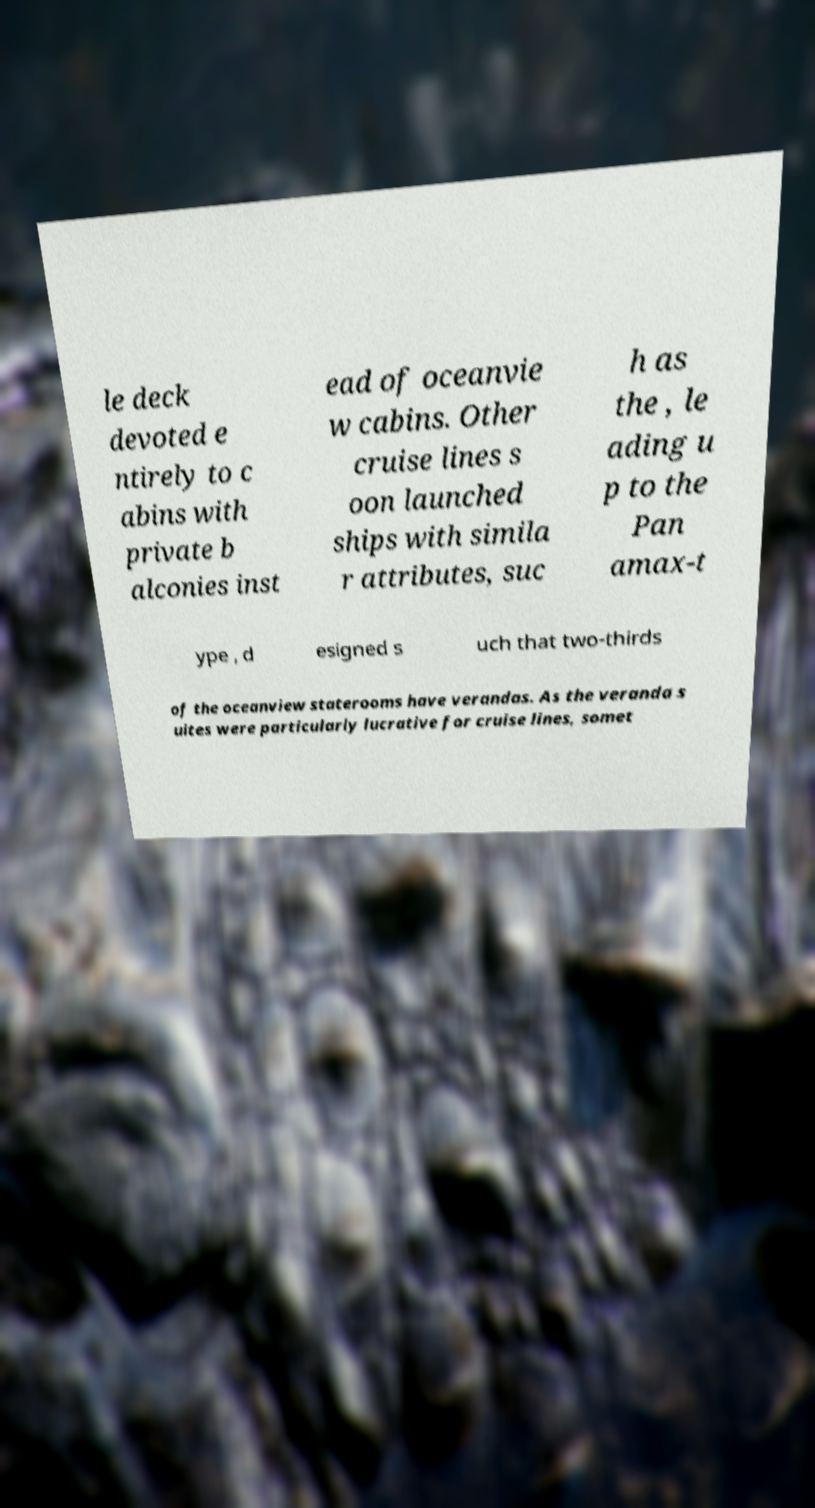Please read and relay the text visible in this image. What does it say? le deck devoted e ntirely to c abins with private b alconies inst ead of oceanvie w cabins. Other cruise lines s oon launched ships with simila r attributes, suc h as the , le ading u p to the Pan amax-t ype , d esigned s uch that two-thirds of the oceanview staterooms have verandas. As the veranda s uites were particularly lucrative for cruise lines, somet 